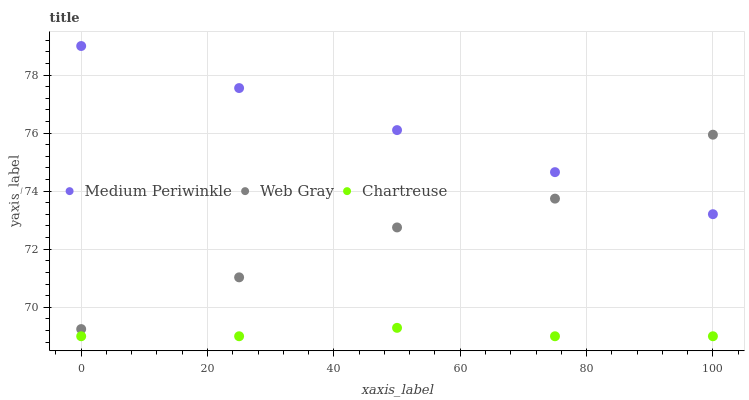Does Chartreuse have the minimum area under the curve?
Answer yes or no. Yes. Does Medium Periwinkle have the maximum area under the curve?
Answer yes or no. Yes. Does Web Gray have the minimum area under the curve?
Answer yes or no. No. Does Web Gray have the maximum area under the curve?
Answer yes or no. No. Is Medium Periwinkle the smoothest?
Answer yes or no. Yes. Is Web Gray the roughest?
Answer yes or no. Yes. Is Web Gray the smoothest?
Answer yes or no. No. Is Medium Periwinkle the roughest?
Answer yes or no. No. Does Chartreuse have the lowest value?
Answer yes or no. Yes. Does Web Gray have the lowest value?
Answer yes or no. No. Does Medium Periwinkle have the highest value?
Answer yes or no. Yes. Does Web Gray have the highest value?
Answer yes or no. No. Is Chartreuse less than Medium Periwinkle?
Answer yes or no. Yes. Is Web Gray greater than Chartreuse?
Answer yes or no. Yes. Does Medium Periwinkle intersect Web Gray?
Answer yes or no. Yes. Is Medium Periwinkle less than Web Gray?
Answer yes or no. No. Is Medium Periwinkle greater than Web Gray?
Answer yes or no. No. Does Chartreuse intersect Medium Periwinkle?
Answer yes or no. No. 